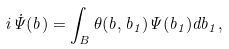Convert formula to latex. <formula><loc_0><loc_0><loc_500><loc_500>i \dot { \Psi } ( { b } ) = \int _ { B } \theta ( { b } , { b } _ { 1 } ) \Psi ( { b } _ { 1 } ) d { b } _ { 1 } ,</formula> 